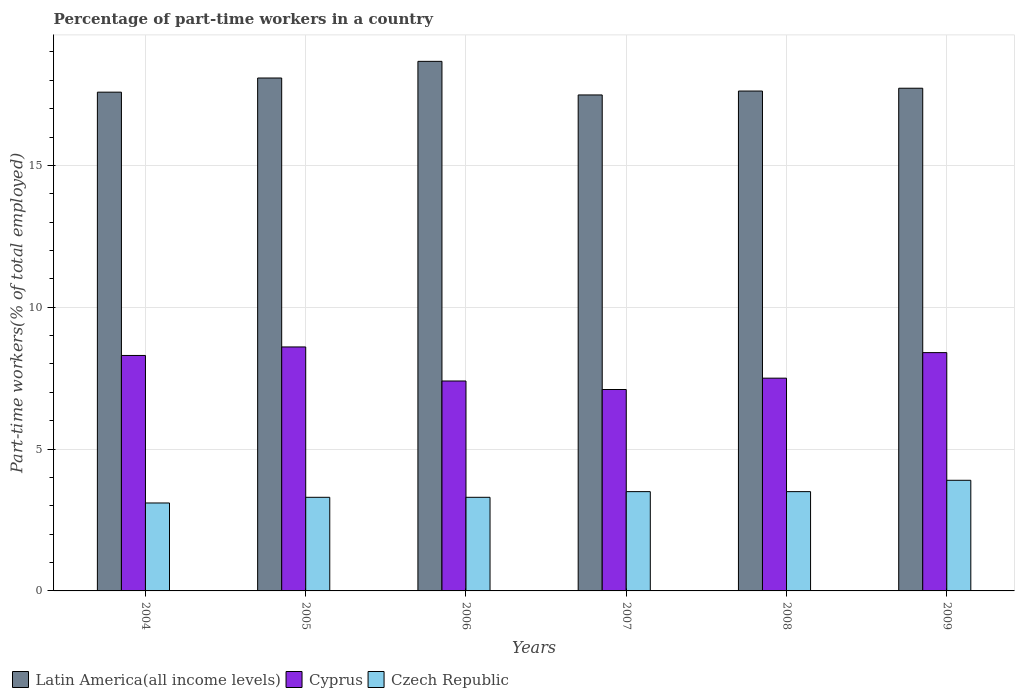How many different coloured bars are there?
Ensure brevity in your answer.  3. How many groups of bars are there?
Keep it short and to the point. 6. How many bars are there on the 5th tick from the left?
Offer a terse response. 3. What is the label of the 4th group of bars from the left?
Offer a very short reply. 2007. In how many cases, is the number of bars for a given year not equal to the number of legend labels?
Give a very brief answer. 0. What is the percentage of part-time workers in Cyprus in 2009?
Your answer should be compact. 8.4. Across all years, what is the maximum percentage of part-time workers in Latin America(all income levels)?
Ensure brevity in your answer.  18.67. Across all years, what is the minimum percentage of part-time workers in Czech Republic?
Provide a short and direct response. 3.1. What is the total percentage of part-time workers in Cyprus in the graph?
Offer a very short reply. 47.3. What is the difference between the percentage of part-time workers in Latin America(all income levels) in 2004 and that in 2009?
Your response must be concise. -0.14. What is the difference between the percentage of part-time workers in Latin America(all income levels) in 2009 and the percentage of part-time workers in Cyprus in 2004?
Ensure brevity in your answer.  9.42. What is the average percentage of part-time workers in Cyprus per year?
Your answer should be compact. 7.88. In the year 2005, what is the difference between the percentage of part-time workers in Cyprus and percentage of part-time workers in Czech Republic?
Your response must be concise. 5.3. What is the ratio of the percentage of part-time workers in Cyprus in 2004 to that in 2005?
Offer a terse response. 0.97. Is the difference between the percentage of part-time workers in Cyprus in 2006 and 2007 greater than the difference between the percentage of part-time workers in Czech Republic in 2006 and 2007?
Provide a succinct answer. Yes. What is the difference between the highest and the second highest percentage of part-time workers in Cyprus?
Provide a succinct answer. 0.2. What is the difference between the highest and the lowest percentage of part-time workers in Czech Republic?
Give a very brief answer. 0.8. In how many years, is the percentage of part-time workers in Cyprus greater than the average percentage of part-time workers in Cyprus taken over all years?
Ensure brevity in your answer.  3. Is the sum of the percentage of part-time workers in Czech Republic in 2008 and 2009 greater than the maximum percentage of part-time workers in Cyprus across all years?
Ensure brevity in your answer.  No. What does the 1st bar from the left in 2005 represents?
Provide a short and direct response. Latin America(all income levels). What does the 3rd bar from the right in 2007 represents?
Provide a short and direct response. Latin America(all income levels). Are all the bars in the graph horizontal?
Your answer should be compact. No. What is the difference between two consecutive major ticks on the Y-axis?
Keep it short and to the point. 5. Are the values on the major ticks of Y-axis written in scientific E-notation?
Your response must be concise. No. How many legend labels are there?
Give a very brief answer. 3. What is the title of the graph?
Your response must be concise. Percentage of part-time workers in a country. Does "Fiji" appear as one of the legend labels in the graph?
Keep it short and to the point. No. What is the label or title of the Y-axis?
Give a very brief answer. Part-time workers(% of total employed). What is the Part-time workers(% of total employed) in Latin America(all income levels) in 2004?
Offer a terse response. 17.58. What is the Part-time workers(% of total employed) in Cyprus in 2004?
Your answer should be very brief. 8.3. What is the Part-time workers(% of total employed) of Czech Republic in 2004?
Give a very brief answer. 3.1. What is the Part-time workers(% of total employed) of Latin America(all income levels) in 2005?
Make the answer very short. 18.08. What is the Part-time workers(% of total employed) in Cyprus in 2005?
Offer a very short reply. 8.6. What is the Part-time workers(% of total employed) of Czech Republic in 2005?
Your answer should be compact. 3.3. What is the Part-time workers(% of total employed) in Latin America(all income levels) in 2006?
Offer a very short reply. 18.67. What is the Part-time workers(% of total employed) of Cyprus in 2006?
Give a very brief answer. 7.4. What is the Part-time workers(% of total employed) in Czech Republic in 2006?
Give a very brief answer. 3.3. What is the Part-time workers(% of total employed) of Latin America(all income levels) in 2007?
Keep it short and to the point. 17.48. What is the Part-time workers(% of total employed) in Cyprus in 2007?
Make the answer very short. 7.1. What is the Part-time workers(% of total employed) in Latin America(all income levels) in 2008?
Make the answer very short. 17.62. What is the Part-time workers(% of total employed) in Cyprus in 2008?
Make the answer very short. 7.5. What is the Part-time workers(% of total employed) of Czech Republic in 2008?
Provide a short and direct response. 3.5. What is the Part-time workers(% of total employed) of Latin America(all income levels) in 2009?
Offer a very short reply. 17.72. What is the Part-time workers(% of total employed) of Cyprus in 2009?
Offer a terse response. 8.4. What is the Part-time workers(% of total employed) in Czech Republic in 2009?
Your response must be concise. 3.9. Across all years, what is the maximum Part-time workers(% of total employed) of Latin America(all income levels)?
Make the answer very short. 18.67. Across all years, what is the maximum Part-time workers(% of total employed) of Cyprus?
Offer a terse response. 8.6. Across all years, what is the maximum Part-time workers(% of total employed) of Czech Republic?
Your answer should be very brief. 3.9. Across all years, what is the minimum Part-time workers(% of total employed) in Latin America(all income levels)?
Your response must be concise. 17.48. Across all years, what is the minimum Part-time workers(% of total employed) of Cyprus?
Ensure brevity in your answer.  7.1. Across all years, what is the minimum Part-time workers(% of total employed) of Czech Republic?
Your response must be concise. 3.1. What is the total Part-time workers(% of total employed) of Latin America(all income levels) in the graph?
Provide a short and direct response. 107.15. What is the total Part-time workers(% of total employed) in Cyprus in the graph?
Provide a short and direct response. 47.3. What is the total Part-time workers(% of total employed) of Czech Republic in the graph?
Provide a succinct answer. 20.6. What is the difference between the Part-time workers(% of total employed) of Latin America(all income levels) in 2004 and that in 2005?
Your answer should be very brief. -0.5. What is the difference between the Part-time workers(% of total employed) of Cyprus in 2004 and that in 2005?
Your answer should be compact. -0.3. What is the difference between the Part-time workers(% of total employed) of Czech Republic in 2004 and that in 2005?
Your answer should be compact. -0.2. What is the difference between the Part-time workers(% of total employed) in Latin America(all income levels) in 2004 and that in 2006?
Your response must be concise. -1.09. What is the difference between the Part-time workers(% of total employed) of Latin America(all income levels) in 2004 and that in 2007?
Offer a terse response. 0.1. What is the difference between the Part-time workers(% of total employed) of Cyprus in 2004 and that in 2007?
Offer a very short reply. 1.2. What is the difference between the Part-time workers(% of total employed) in Latin America(all income levels) in 2004 and that in 2008?
Make the answer very short. -0.04. What is the difference between the Part-time workers(% of total employed) of Cyprus in 2004 and that in 2008?
Provide a short and direct response. 0.8. What is the difference between the Part-time workers(% of total employed) of Czech Republic in 2004 and that in 2008?
Keep it short and to the point. -0.4. What is the difference between the Part-time workers(% of total employed) in Latin America(all income levels) in 2004 and that in 2009?
Keep it short and to the point. -0.14. What is the difference between the Part-time workers(% of total employed) in Latin America(all income levels) in 2005 and that in 2006?
Keep it short and to the point. -0.59. What is the difference between the Part-time workers(% of total employed) in Latin America(all income levels) in 2005 and that in 2007?
Offer a very short reply. 0.6. What is the difference between the Part-time workers(% of total employed) of Cyprus in 2005 and that in 2007?
Keep it short and to the point. 1.5. What is the difference between the Part-time workers(% of total employed) in Czech Republic in 2005 and that in 2007?
Make the answer very short. -0.2. What is the difference between the Part-time workers(% of total employed) in Latin America(all income levels) in 2005 and that in 2008?
Provide a short and direct response. 0.46. What is the difference between the Part-time workers(% of total employed) of Cyprus in 2005 and that in 2008?
Make the answer very short. 1.1. What is the difference between the Part-time workers(% of total employed) of Latin America(all income levels) in 2005 and that in 2009?
Keep it short and to the point. 0.36. What is the difference between the Part-time workers(% of total employed) of Cyprus in 2005 and that in 2009?
Make the answer very short. 0.2. What is the difference between the Part-time workers(% of total employed) of Czech Republic in 2005 and that in 2009?
Offer a very short reply. -0.6. What is the difference between the Part-time workers(% of total employed) of Latin America(all income levels) in 2006 and that in 2007?
Ensure brevity in your answer.  1.18. What is the difference between the Part-time workers(% of total employed) in Czech Republic in 2006 and that in 2007?
Make the answer very short. -0.2. What is the difference between the Part-time workers(% of total employed) in Latin America(all income levels) in 2006 and that in 2008?
Keep it short and to the point. 1.05. What is the difference between the Part-time workers(% of total employed) in Cyprus in 2006 and that in 2008?
Give a very brief answer. -0.1. What is the difference between the Part-time workers(% of total employed) of Latin America(all income levels) in 2006 and that in 2009?
Provide a succinct answer. 0.95. What is the difference between the Part-time workers(% of total employed) of Latin America(all income levels) in 2007 and that in 2008?
Offer a terse response. -0.14. What is the difference between the Part-time workers(% of total employed) in Latin America(all income levels) in 2007 and that in 2009?
Provide a succinct answer. -0.24. What is the difference between the Part-time workers(% of total employed) in Cyprus in 2007 and that in 2009?
Provide a short and direct response. -1.3. What is the difference between the Part-time workers(% of total employed) in Czech Republic in 2007 and that in 2009?
Provide a succinct answer. -0.4. What is the difference between the Part-time workers(% of total employed) of Latin America(all income levels) in 2008 and that in 2009?
Your answer should be very brief. -0.1. What is the difference between the Part-time workers(% of total employed) in Cyprus in 2008 and that in 2009?
Keep it short and to the point. -0.9. What is the difference between the Part-time workers(% of total employed) in Czech Republic in 2008 and that in 2009?
Your answer should be very brief. -0.4. What is the difference between the Part-time workers(% of total employed) of Latin America(all income levels) in 2004 and the Part-time workers(% of total employed) of Cyprus in 2005?
Give a very brief answer. 8.98. What is the difference between the Part-time workers(% of total employed) in Latin America(all income levels) in 2004 and the Part-time workers(% of total employed) in Czech Republic in 2005?
Your answer should be compact. 14.28. What is the difference between the Part-time workers(% of total employed) in Cyprus in 2004 and the Part-time workers(% of total employed) in Czech Republic in 2005?
Provide a succinct answer. 5. What is the difference between the Part-time workers(% of total employed) of Latin America(all income levels) in 2004 and the Part-time workers(% of total employed) of Cyprus in 2006?
Give a very brief answer. 10.18. What is the difference between the Part-time workers(% of total employed) in Latin America(all income levels) in 2004 and the Part-time workers(% of total employed) in Czech Republic in 2006?
Keep it short and to the point. 14.28. What is the difference between the Part-time workers(% of total employed) of Cyprus in 2004 and the Part-time workers(% of total employed) of Czech Republic in 2006?
Your answer should be compact. 5. What is the difference between the Part-time workers(% of total employed) in Latin America(all income levels) in 2004 and the Part-time workers(% of total employed) in Cyprus in 2007?
Keep it short and to the point. 10.48. What is the difference between the Part-time workers(% of total employed) in Latin America(all income levels) in 2004 and the Part-time workers(% of total employed) in Czech Republic in 2007?
Your answer should be compact. 14.08. What is the difference between the Part-time workers(% of total employed) of Latin America(all income levels) in 2004 and the Part-time workers(% of total employed) of Cyprus in 2008?
Your response must be concise. 10.08. What is the difference between the Part-time workers(% of total employed) of Latin America(all income levels) in 2004 and the Part-time workers(% of total employed) of Czech Republic in 2008?
Offer a very short reply. 14.08. What is the difference between the Part-time workers(% of total employed) in Latin America(all income levels) in 2004 and the Part-time workers(% of total employed) in Cyprus in 2009?
Your answer should be very brief. 9.18. What is the difference between the Part-time workers(% of total employed) in Latin America(all income levels) in 2004 and the Part-time workers(% of total employed) in Czech Republic in 2009?
Provide a succinct answer. 13.68. What is the difference between the Part-time workers(% of total employed) in Cyprus in 2004 and the Part-time workers(% of total employed) in Czech Republic in 2009?
Make the answer very short. 4.4. What is the difference between the Part-time workers(% of total employed) of Latin America(all income levels) in 2005 and the Part-time workers(% of total employed) of Cyprus in 2006?
Ensure brevity in your answer.  10.68. What is the difference between the Part-time workers(% of total employed) of Latin America(all income levels) in 2005 and the Part-time workers(% of total employed) of Czech Republic in 2006?
Make the answer very short. 14.78. What is the difference between the Part-time workers(% of total employed) in Latin America(all income levels) in 2005 and the Part-time workers(% of total employed) in Cyprus in 2007?
Your answer should be very brief. 10.98. What is the difference between the Part-time workers(% of total employed) in Latin America(all income levels) in 2005 and the Part-time workers(% of total employed) in Czech Republic in 2007?
Your response must be concise. 14.58. What is the difference between the Part-time workers(% of total employed) in Cyprus in 2005 and the Part-time workers(% of total employed) in Czech Republic in 2007?
Keep it short and to the point. 5.1. What is the difference between the Part-time workers(% of total employed) in Latin America(all income levels) in 2005 and the Part-time workers(% of total employed) in Cyprus in 2008?
Your answer should be compact. 10.58. What is the difference between the Part-time workers(% of total employed) in Latin America(all income levels) in 2005 and the Part-time workers(% of total employed) in Czech Republic in 2008?
Ensure brevity in your answer.  14.58. What is the difference between the Part-time workers(% of total employed) in Latin America(all income levels) in 2005 and the Part-time workers(% of total employed) in Cyprus in 2009?
Provide a succinct answer. 9.68. What is the difference between the Part-time workers(% of total employed) in Latin America(all income levels) in 2005 and the Part-time workers(% of total employed) in Czech Republic in 2009?
Give a very brief answer. 14.18. What is the difference between the Part-time workers(% of total employed) in Latin America(all income levels) in 2006 and the Part-time workers(% of total employed) in Cyprus in 2007?
Give a very brief answer. 11.57. What is the difference between the Part-time workers(% of total employed) in Latin America(all income levels) in 2006 and the Part-time workers(% of total employed) in Czech Republic in 2007?
Make the answer very short. 15.17. What is the difference between the Part-time workers(% of total employed) of Cyprus in 2006 and the Part-time workers(% of total employed) of Czech Republic in 2007?
Your answer should be compact. 3.9. What is the difference between the Part-time workers(% of total employed) in Latin America(all income levels) in 2006 and the Part-time workers(% of total employed) in Cyprus in 2008?
Ensure brevity in your answer.  11.17. What is the difference between the Part-time workers(% of total employed) in Latin America(all income levels) in 2006 and the Part-time workers(% of total employed) in Czech Republic in 2008?
Offer a very short reply. 15.17. What is the difference between the Part-time workers(% of total employed) in Latin America(all income levels) in 2006 and the Part-time workers(% of total employed) in Cyprus in 2009?
Offer a very short reply. 10.27. What is the difference between the Part-time workers(% of total employed) in Latin America(all income levels) in 2006 and the Part-time workers(% of total employed) in Czech Republic in 2009?
Your answer should be very brief. 14.77. What is the difference between the Part-time workers(% of total employed) of Latin America(all income levels) in 2007 and the Part-time workers(% of total employed) of Cyprus in 2008?
Your response must be concise. 9.98. What is the difference between the Part-time workers(% of total employed) in Latin America(all income levels) in 2007 and the Part-time workers(% of total employed) in Czech Republic in 2008?
Your answer should be compact. 13.98. What is the difference between the Part-time workers(% of total employed) of Latin America(all income levels) in 2007 and the Part-time workers(% of total employed) of Cyprus in 2009?
Provide a short and direct response. 9.08. What is the difference between the Part-time workers(% of total employed) of Latin America(all income levels) in 2007 and the Part-time workers(% of total employed) of Czech Republic in 2009?
Offer a very short reply. 13.58. What is the difference between the Part-time workers(% of total employed) of Latin America(all income levels) in 2008 and the Part-time workers(% of total employed) of Cyprus in 2009?
Provide a succinct answer. 9.22. What is the difference between the Part-time workers(% of total employed) in Latin America(all income levels) in 2008 and the Part-time workers(% of total employed) in Czech Republic in 2009?
Offer a terse response. 13.72. What is the difference between the Part-time workers(% of total employed) in Cyprus in 2008 and the Part-time workers(% of total employed) in Czech Republic in 2009?
Ensure brevity in your answer.  3.6. What is the average Part-time workers(% of total employed) of Latin America(all income levels) per year?
Give a very brief answer. 17.86. What is the average Part-time workers(% of total employed) in Cyprus per year?
Keep it short and to the point. 7.88. What is the average Part-time workers(% of total employed) in Czech Republic per year?
Ensure brevity in your answer.  3.43. In the year 2004, what is the difference between the Part-time workers(% of total employed) of Latin America(all income levels) and Part-time workers(% of total employed) of Cyprus?
Give a very brief answer. 9.28. In the year 2004, what is the difference between the Part-time workers(% of total employed) of Latin America(all income levels) and Part-time workers(% of total employed) of Czech Republic?
Provide a short and direct response. 14.48. In the year 2004, what is the difference between the Part-time workers(% of total employed) of Cyprus and Part-time workers(% of total employed) of Czech Republic?
Give a very brief answer. 5.2. In the year 2005, what is the difference between the Part-time workers(% of total employed) of Latin America(all income levels) and Part-time workers(% of total employed) of Cyprus?
Make the answer very short. 9.48. In the year 2005, what is the difference between the Part-time workers(% of total employed) in Latin America(all income levels) and Part-time workers(% of total employed) in Czech Republic?
Offer a terse response. 14.78. In the year 2005, what is the difference between the Part-time workers(% of total employed) in Cyprus and Part-time workers(% of total employed) in Czech Republic?
Your answer should be very brief. 5.3. In the year 2006, what is the difference between the Part-time workers(% of total employed) in Latin America(all income levels) and Part-time workers(% of total employed) in Cyprus?
Provide a short and direct response. 11.27. In the year 2006, what is the difference between the Part-time workers(% of total employed) of Latin America(all income levels) and Part-time workers(% of total employed) of Czech Republic?
Keep it short and to the point. 15.37. In the year 2006, what is the difference between the Part-time workers(% of total employed) of Cyprus and Part-time workers(% of total employed) of Czech Republic?
Ensure brevity in your answer.  4.1. In the year 2007, what is the difference between the Part-time workers(% of total employed) of Latin America(all income levels) and Part-time workers(% of total employed) of Cyprus?
Make the answer very short. 10.38. In the year 2007, what is the difference between the Part-time workers(% of total employed) in Latin America(all income levels) and Part-time workers(% of total employed) in Czech Republic?
Your response must be concise. 13.98. In the year 2008, what is the difference between the Part-time workers(% of total employed) of Latin America(all income levels) and Part-time workers(% of total employed) of Cyprus?
Offer a terse response. 10.12. In the year 2008, what is the difference between the Part-time workers(% of total employed) in Latin America(all income levels) and Part-time workers(% of total employed) in Czech Republic?
Your answer should be very brief. 14.12. In the year 2008, what is the difference between the Part-time workers(% of total employed) in Cyprus and Part-time workers(% of total employed) in Czech Republic?
Offer a very short reply. 4. In the year 2009, what is the difference between the Part-time workers(% of total employed) in Latin America(all income levels) and Part-time workers(% of total employed) in Cyprus?
Provide a short and direct response. 9.32. In the year 2009, what is the difference between the Part-time workers(% of total employed) in Latin America(all income levels) and Part-time workers(% of total employed) in Czech Republic?
Your answer should be very brief. 13.82. In the year 2009, what is the difference between the Part-time workers(% of total employed) of Cyprus and Part-time workers(% of total employed) of Czech Republic?
Keep it short and to the point. 4.5. What is the ratio of the Part-time workers(% of total employed) in Latin America(all income levels) in 2004 to that in 2005?
Provide a short and direct response. 0.97. What is the ratio of the Part-time workers(% of total employed) of Cyprus in 2004 to that in 2005?
Your answer should be compact. 0.97. What is the ratio of the Part-time workers(% of total employed) of Czech Republic in 2004 to that in 2005?
Offer a very short reply. 0.94. What is the ratio of the Part-time workers(% of total employed) in Latin America(all income levels) in 2004 to that in 2006?
Provide a succinct answer. 0.94. What is the ratio of the Part-time workers(% of total employed) in Cyprus in 2004 to that in 2006?
Make the answer very short. 1.12. What is the ratio of the Part-time workers(% of total employed) in Czech Republic in 2004 to that in 2006?
Ensure brevity in your answer.  0.94. What is the ratio of the Part-time workers(% of total employed) in Latin America(all income levels) in 2004 to that in 2007?
Offer a terse response. 1.01. What is the ratio of the Part-time workers(% of total employed) in Cyprus in 2004 to that in 2007?
Provide a short and direct response. 1.17. What is the ratio of the Part-time workers(% of total employed) of Czech Republic in 2004 to that in 2007?
Your response must be concise. 0.89. What is the ratio of the Part-time workers(% of total employed) of Cyprus in 2004 to that in 2008?
Keep it short and to the point. 1.11. What is the ratio of the Part-time workers(% of total employed) of Czech Republic in 2004 to that in 2008?
Provide a succinct answer. 0.89. What is the ratio of the Part-time workers(% of total employed) in Latin America(all income levels) in 2004 to that in 2009?
Provide a short and direct response. 0.99. What is the ratio of the Part-time workers(% of total employed) of Czech Republic in 2004 to that in 2009?
Ensure brevity in your answer.  0.79. What is the ratio of the Part-time workers(% of total employed) of Latin America(all income levels) in 2005 to that in 2006?
Give a very brief answer. 0.97. What is the ratio of the Part-time workers(% of total employed) in Cyprus in 2005 to that in 2006?
Provide a short and direct response. 1.16. What is the ratio of the Part-time workers(% of total employed) of Latin America(all income levels) in 2005 to that in 2007?
Offer a terse response. 1.03. What is the ratio of the Part-time workers(% of total employed) in Cyprus in 2005 to that in 2007?
Your answer should be compact. 1.21. What is the ratio of the Part-time workers(% of total employed) of Czech Republic in 2005 to that in 2007?
Offer a very short reply. 0.94. What is the ratio of the Part-time workers(% of total employed) of Latin America(all income levels) in 2005 to that in 2008?
Provide a short and direct response. 1.03. What is the ratio of the Part-time workers(% of total employed) in Cyprus in 2005 to that in 2008?
Give a very brief answer. 1.15. What is the ratio of the Part-time workers(% of total employed) in Czech Republic in 2005 to that in 2008?
Make the answer very short. 0.94. What is the ratio of the Part-time workers(% of total employed) of Latin America(all income levels) in 2005 to that in 2009?
Offer a very short reply. 1.02. What is the ratio of the Part-time workers(% of total employed) of Cyprus in 2005 to that in 2009?
Give a very brief answer. 1.02. What is the ratio of the Part-time workers(% of total employed) of Czech Republic in 2005 to that in 2009?
Give a very brief answer. 0.85. What is the ratio of the Part-time workers(% of total employed) of Latin America(all income levels) in 2006 to that in 2007?
Keep it short and to the point. 1.07. What is the ratio of the Part-time workers(% of total employed) in Cyprus in 2006 to that in 2007?
Your response must be concise. 1.04. What is the ratio of the Part-time workers(% of total employed) in Czech Republic in 2006 to that in 2007?
Make the answer very short. 0.94. What is the ratio of the Part-time workers(% of total employed) of Latin America(all income levels) in 2006 to that in 2008?
Your answer should be very brief. 1.06. What is the ratio of the Part-time workers(% of total employed) of Cyprus in 2006 to that in 2008?
Keep it short and to the point. 0.99. What is the ratio of the Part-time workers(% of total employed) in Czech Republic in 2006 to that in 2008?
Offer a very short reply. 0.94. What is the ratio of the Part-time workers(% of total employed) in Latin America(all income levels) in 2006 to that in 2009?
Your answer should be very brief. 1.05. What is the ratio of the Part-time workers(% of total employed) of Cyprus in 2006 to that in 2009?
Provide a short and direct response. 0.88. What is the ratio of the Part-time workers(% of total employed) in Czech Republic in 2006 to that in 2009?
Your answer should be compact. 0.85. What is the ratio of the Part-time workers(% of total employed) in Latin America(all income levels) in 2007 to that in 2008?
Ensure brevity in your answer.  0.99. What is the ratio of the Part-time workers(% of total employed) in Cyprus in 2007 to that in 2008?
Your answer should be compact. 0.95. What is the ratio of the Part-time workers(% of total employed) of Latin America(all income levels) in 2007 to that in 2009?
Offer a terse response. 0.99. What is the ratio of the Part-time workers(% of total employed) in Cyprus in 2007 to that in 2009?
Ensure brevity in your answer.  0.85. What is the ratio of the Part-time workers(% of total employed) of Czech Republic in 2007 to that in 2009?
Your answer should be very brief. 0.9. What is the ratio of the Part-time workers(% of total employed) of Cyprus in 2008 to that in 2009?
Your answer should be very brief. 0.89. What is the ratio of the Part-time workers(% of total employed) in Czech Republic in 2008 to that in 2009?
Make the answer very short. 0.9. What is the difference between the highest and the second highest Part-time workers(% of total employed) of Latin America(all income levels)?
Make the answer very short. 0.59. What is the difference between the highest and the second highest Part-time workers(% of total employed) in Czech Republic?
Provide a succinct answer. 0.4. What is the difference between the highest and the lowest Part-time workers(% of total employed) in Latin America(all income levels)?
Offer a very short reply. 1.18. What is the difference between the highest and the lowest Part-time workers(% of total employed) in Cyprus?
Give a very brief answer. 1.5. What is the difference between the highest and the lowest Part-time workers(% of total employed) of Czech Republic?
Offer a terse response. 0.8. 